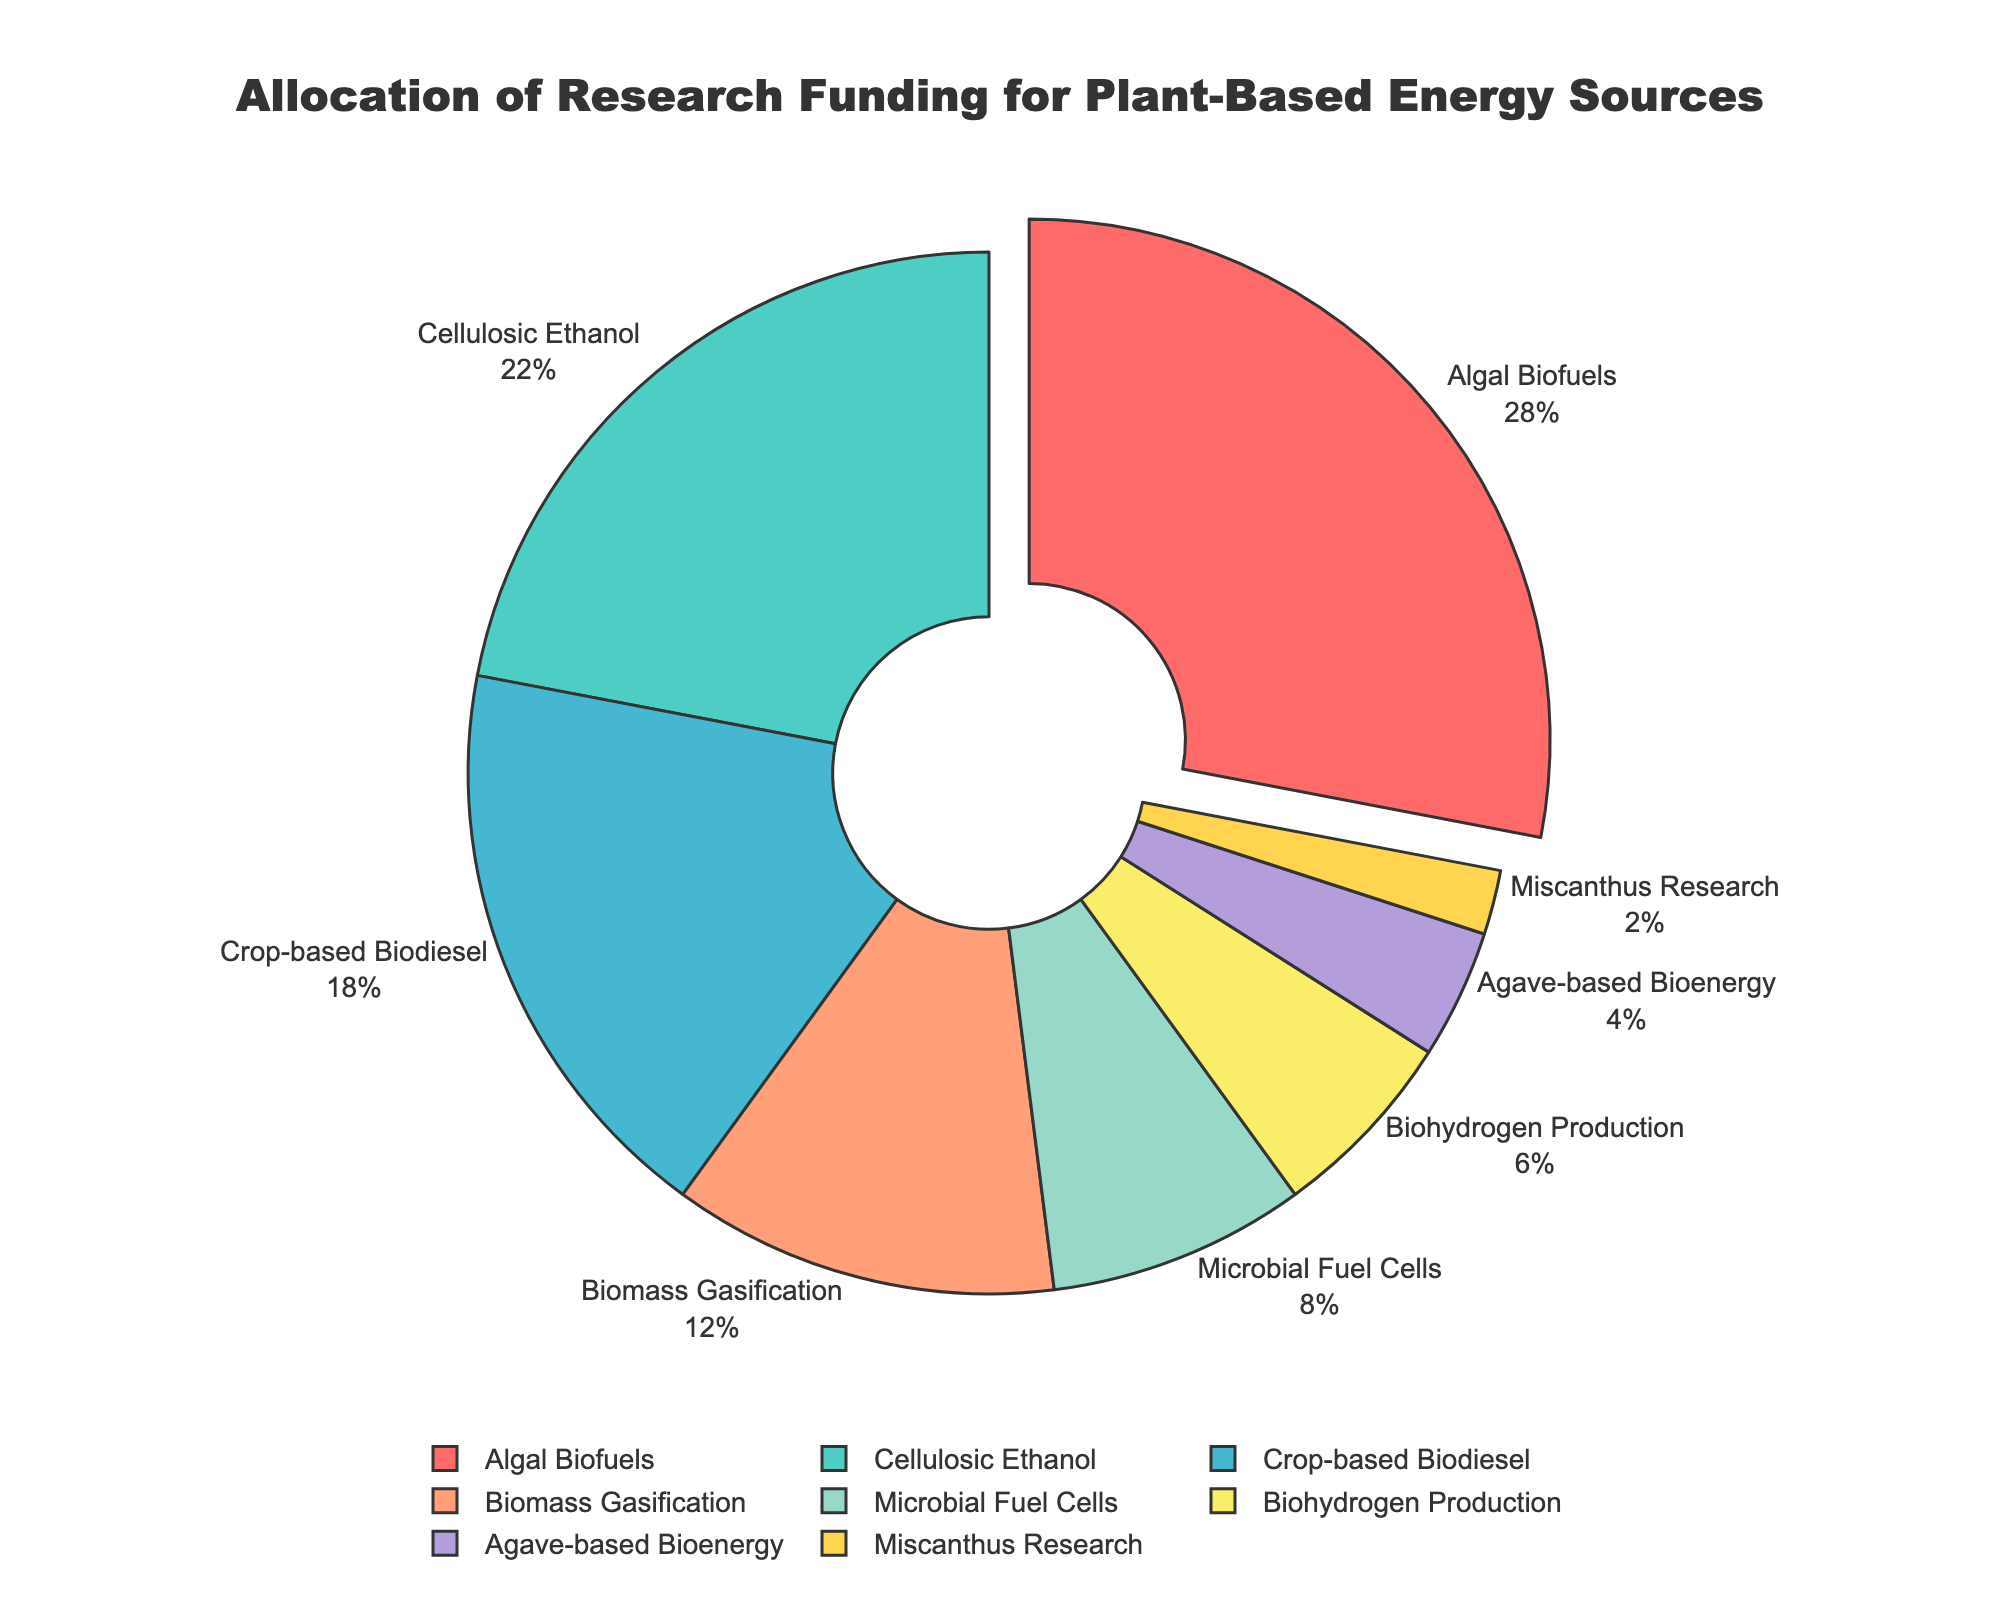What is the research area that received the highest percentage of funding? The area with the highest percentage of funding is identified by the largest segment in the pie chart, which is visually drawn away from the center. The "Algal Biofuels" segment (28%) is pulled out more than others.
Answer: Algal Biofuels How much more funding does Algal Biofuels receive compared to Biohydrogen Production? Find the funding percentages for Algal Biofuels (28%) and Biohydrogen Production (6%), then subtract the latter from the former: 28% - 6% = 22%.
Answer: 22% Which research area received the second-lowest percentage of funding? The segment with the second-smallest size after the smallest (Miscanthus Research at 2%) is Agave-based Bioenergy at 4%.
Answer: Agave-based Bioenergy What is the combined percentage of funding allocated to Cellulosic Ethanol and Crop-based Biodiesel? Sum the funding percentages for Cellulosic Ethanol (22%) and Crop-based Biodiesel (18%): 22% + 18% = 40%.
Answer: 40% Is the funding for Microbial Fuel Cells greater than the funding for Agave-based Bioenergy? Compare their funding percentages: Microbial Fuel Cells receives 8%, while Agave-based Bioenergy receives 4%. Since 8% > 4%, the answer is yes.
Answer: Yes Which three research areas collectively have the smallest funding allocation? Identify the three smallest segments: Miscanthus Research (2%), Agave-based Bioenergy (4%), and Biohydrogen Production (6%) and then sum them: 2% + 4% + 6% = 12%.
Answer: Miscanthus Research, Agave-based Bioenergy, Biohydrogen Production What is the average funding percentage for the four research areas with the highest allocation? Identify the four highest allocations: Algal Biofuels (28%), Cellulosic Ethanol (22%), Crop-based Biodiesel (18%), and Biomass Gasification (12%), then calculate their average sum: (28% + 22% + 18% + 12%) / 4 = 80% / 4 = 20%.
Answer: 20% What is the difference in percentage allocation between the top-funded and least-funded research areas? Identify the highest (Algal Biofuels at 28%) and the lowest (Miscanthus Research at 2%) allocations, and find the difference: 28% - 2% = 26%.
Answer: 26% Which research areas share the same color or have similar hues? Observe the color pattern of the segments. For example, Biomass Gasification (orange/peach hue) and Agave-based Bioenergy (yellow) could be considered hues of the same color family (warm colors).
Answer: Biomass Gasification and Agave-based Bioenergy How many research areas have funding allocation percentages below 10%? Identify and count the segments with less than 10% funding: Microbial Fuel Cells (8%), Biohydrogen Production (6%), Agave-based Bioenergy (4%), and Miscanthus Research (2%). There are 4 such areas.
Answer: 4 